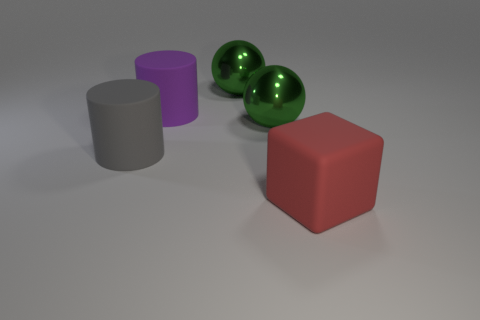How many large objects are either spheres or red matte blocks?
Provide a succinct answer. 3. There is a purple object that is the same shape as the gray matte object; what is its size?
Offer a very short reply. Large. Are there any other things that have the same size as the gray matte object?
Offer a terse response. Yes. What material is the ball that is in front of the matte cylinder that is behind the gray cylinder?
Your answer should be very brief. Metal. How many matte objects are either large green things or tiny blue cylinders?
Keep it short and to the point. 0. What color is the other object that is the same shape as the gray thing?
Your answer should be very brief. Purple. There is a big green shiny thing that is behind the purple cylinder; is there a large red matte thing right of it?
Your response must be concise. Yes. How many large things are on the right side of the big purple cylinder and on the left side of the large red rubber thing?
Provide a short and direct response. 2. How many big red blocks have the same material as the large purple cylinder?
Offer a very short reply. 1. What is the size of the green shiny object behind the green shiny thing in front of the big purple thing?
Your response must be concise. Large. 